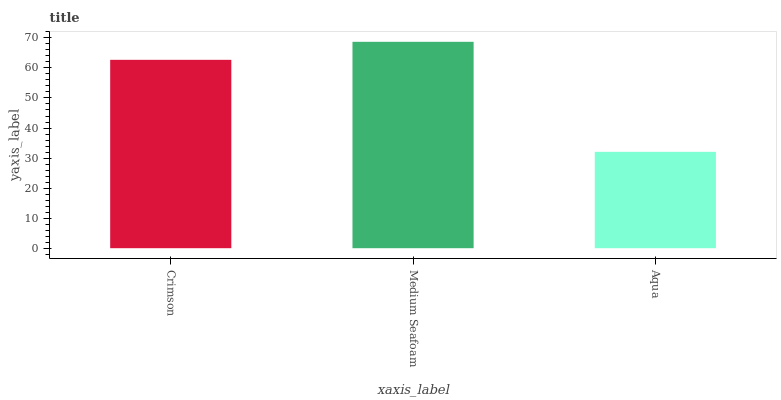Is Aqua the minimum?
Answer yes or no. Yes. Is Medium Seafoam the maximum?
Answer yes or no. Yes. Is Medium Seafoam the minimum?
Answer yes or no. No. Is Aqua the maximum?
Answer yes or no. No. Is Medium Seafoam greater than Aqua?
Answer yes or no. Yes. Is Aqua less than Medium Seafoam?
Answer yes or no. Yes. Is Aqua greater than Medium Seafoam?
Answer yes or no. No. Is Medium Seafoam less than Aqua?
Answer yes or no. No. Is Crimson the high median?
Answer yes or no. Yes. Is Crimson the low median?
Answer yes or no. Yes. Is Medium Seafoam the high median?
Answer yes or no. No. Is Aqua the low median?
Answer yes or no. No. 